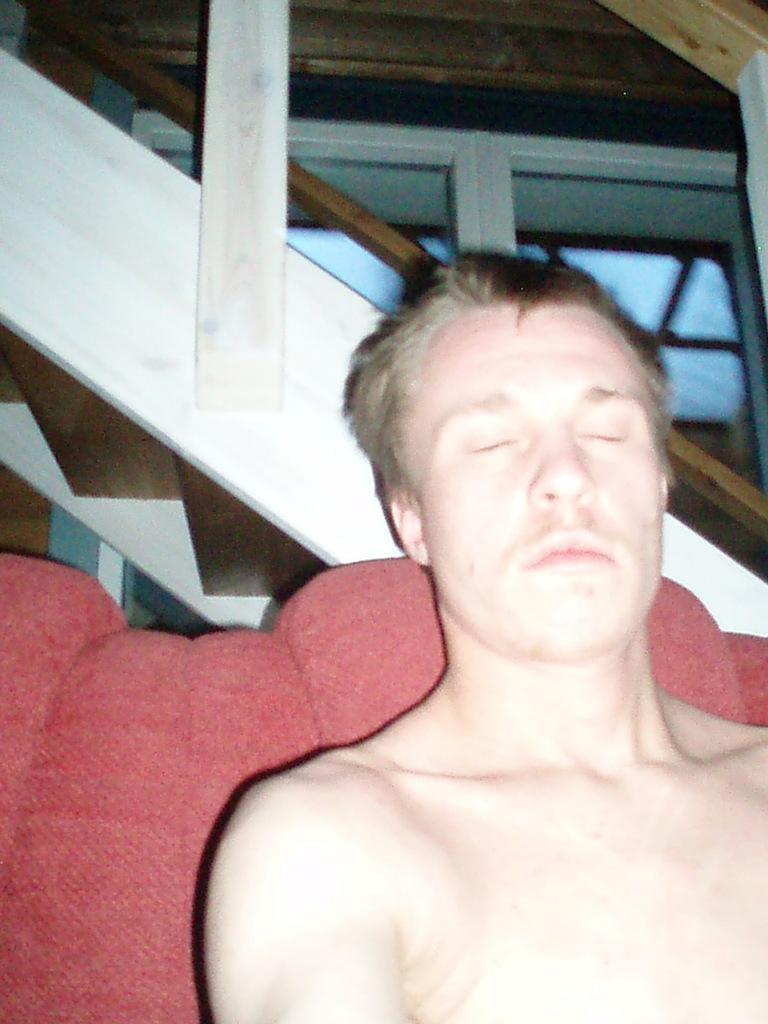Please provide a concise description of this image. In the foreground of this image, there is a man closing eyes and sitting on a red sofa. In the background, there is a railing and it seems like a window to the wall in the background. 